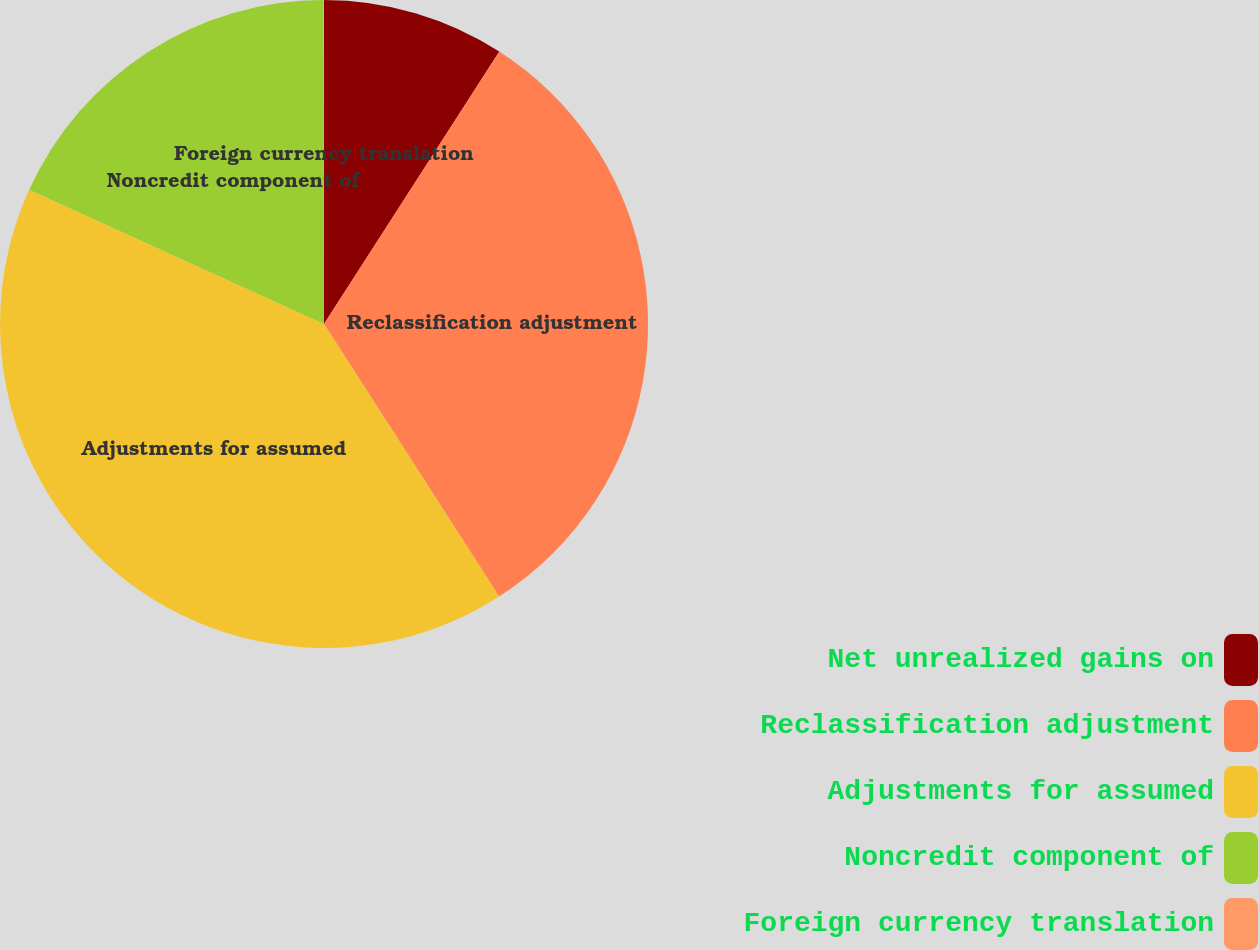Convert chart. <chart><loc_0><loc_0><loc_500><loc_500><pie_chart><fcel>Net unrealized gains on<fcel>Reclassification adjustment<fcel>Adjustments for assumed<fcel>Noncredit component of<fcel>Foreign currency translation<nl><fcel>9.1%<fcel>31.81%<fcel>40.89%<fcel>18.18%<fcel>0.02%<nl></chart> 